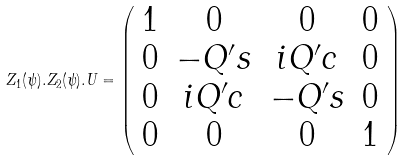<formula> <loc_0><loc_0><loc_500><loc_500>Z _ { 1 } ( \psi ) . Z _ { 2 } ( \psi ) . U = \left ( \begin{array} { c c c c } 1 & 0 & 0 & 0 \\ 0 & - Q ^ { \prime } s & i Q ^ { \prime } c & 0 \\ 0 & i Q ^ { \prime } c & - Q ^ { \prime } s & 0 \\ 0 & 0 & 0 & 1 \end{array} \right )</formula> 